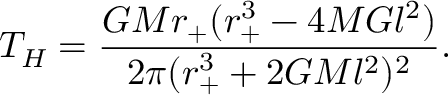<formula> <loc_0><loc_0><loc_500><loc_500>T _ { H } = \frac { G M r _ { + } ( r _ { + } ^ { 3 } - 4 M G l ^ { 2 } ) } { 2 \pi ( r _ { + } ^ { 3 } + 2 G M l ^ { 2 } ) ^ { 2 } } .</formula> 